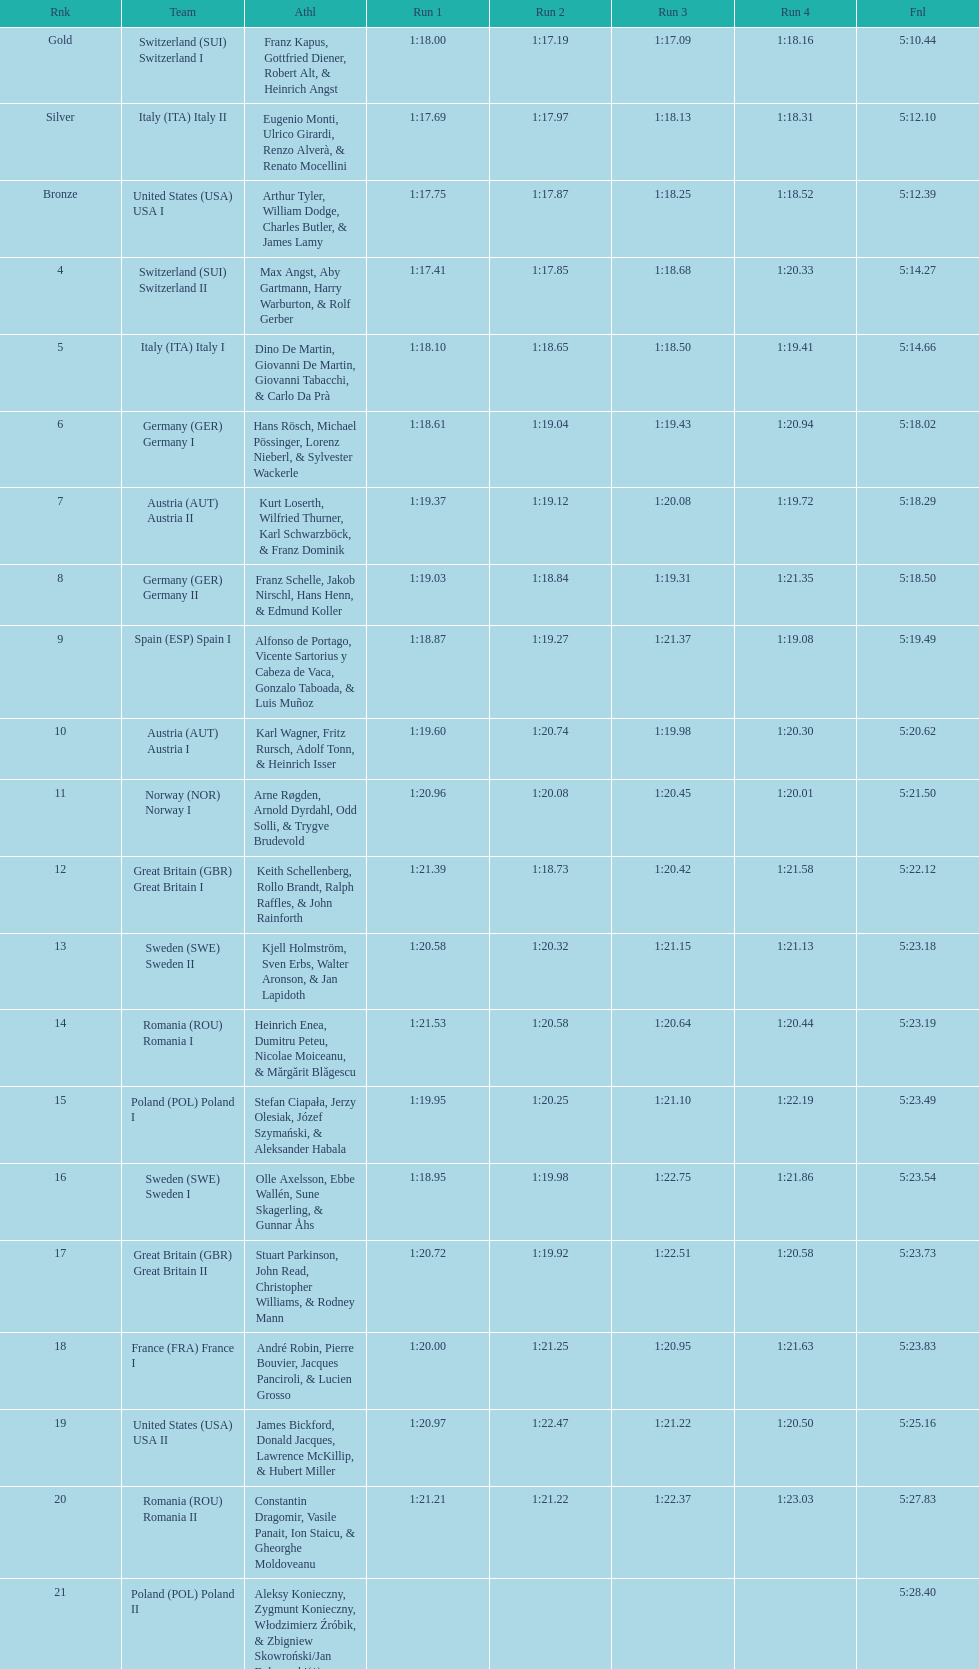Parse the full table. {'header': ['Rnk', 'Team', 'Athl', 'Run 1', 'Run 2', 'Run 3', 'Run 4', 'Fnl'], 'rows': [['Gold', 'Switzerland\xa0(SUI) Switzerland I', 'Franz Kapus, Gottfried Diener, Robert Alt, & Heinrich Angst', '1:18.00', '1:17.19', '1:17.09', '1:18.16', '5:10.44'], ['Silver', 'Italy\xa0(ITA) Italy II', 'Eugenio Monti, Ulrico Girardi, Renzo Alverà, & Renato Mocellini', '1:17.69', '1:17.97', '1:18.13', '1:18.31', '5:12.10'], ['Bronze', 'United States\xa0(USA) USA I', 'Arthur Tyler, William Dodge, Charles Butler, & James Lamy', '1:17.75', '1:17.87', '1:18.25', '1:18.52', '5:12.39'], ['4', 'Switzerland\xa0(SUI) Switzerland II', 'Max Angst, Aby Gartmann, Harry Warburton, & Rolf Gerber', '1:17.41', '1:17.85', '1:18.68', '1:20.33', '5:14.27'], ['5', 'Italy\xa0(ITA) Italy I', 'Dino De Martin, Giovanni De Martin, Giovanni Tabacchi, & Carlo Da Prà', '1:18.10', '1:18.65', '1:18.50', '1:19.41', '5:14.66'], ['6', 'Germany\xa0(GER) Germany I', 'Hans Rösch, Michael Pössinger, Lorenz Nieberl, & Sylvester Wackerle', '1:18.61', '1:19.04', '1:19.43', '1:20.94', '5:18.02'], ['7', 'Austria\xa0(AUT) Austria II', 'Kurt Loserth, Wilfried Thurner, Karl Schwarzböck, & Franz Dominik', '1:19.37', '1:19.12', '1:20.08', '1:19.72', '5:18.29'], ['8', 'Germany\xa0(GER) Germany II', 'Franz Schelle, Jakob Nirschl, Hans Henn, & Edmund Koller', '1:19.03', '1:18.84', '1:19.31', '1:21.35', '5:18.50'], ['9', 'Spain\xa0(ESP) Spain I', 'Alfonso de Portago, Vicente Sartorius y Cabeza de Vaca, Gonzalo Taboada, & Luis Muñoz', '1:18.87', '1:19.27', '1:21.37', '1:19.08', '5:19.49'], ['10', 'Austria\xa0(AUT) Austria I', 'Karl Wagner, Fritz Rursch, Adolf Tonn, & Heinrich Isser', '1:19.60', '1:20.74', '1:19.98', '1:20.30', '5:20.62'], ['11', 'Norway\xa0(NOR) Norway I', 'Arne Røgden, Arnold Dyrdahl, Odd Solli, & Trygve Brudevold', '1:20.96', '1:20.08', '1:20.45', '1:20.01', '5:21.50'], ['12', 'Great Britain\xa0(GBR) Great Britain I', 'Keith Schellenberg, Rollo Brandt, Ralph Raffles, & John Rainforth', '1:21.39', '1:18.73', '1:20.42', '1:21.58', '5:22.12'], ['13', 'Sweden\xa0(SWE) Sweden II', 'Kjell Holmström, Sven Erbs, Walter Aronson, & Jan Lapidoth', '1:20.58', '1:20.32', '1:21.15', '1:21.13', '5:23.18'], ['14', 'Romania\xa0(ROU) Romania I', 'Heinrich Enea, Dumitru Peteu, Nicolae Moiceanu, & Mărgărit Blăgescu', '1:21.53', '1:20.58', '1:20.64', '1:20.44', '5:23.19'], ['15', 'Poland\xa0(POL) Poland I', 'Stefan Ciapała, Jerzy Olesiak, Józef Szymański, & Aleksander Habala', '1:19.95', '1:20.25', '1:21.10', '1:22.19', '5:23.49'], ['16', 'Sweden\xa0(SWE) Sweden I', 'Olle Axelsson, Ebbe Wallén, Sune Skagerling, & Gunnar Åhs', '1:18.95', '1:19.98', '1:22.75', '1:21.86', '5:23.54'], ['17', 'Great Britain\xa0(GBR) Great Britain II', 'Stuart Parkinson, John Read, Christopher Williams, & Rodney Mann', '1:20.72', '1:19.92', '1:22.51', '1:20.58', '5:23.73'], ['18', 'France\xa0(FRA) France I', 'André Robin, Pierre Bouvier, Jacques Panciroli, & Lucien Grosso', '1:20.00', '1:21.25', '1:20.95', '1:21.63', '5:23.83'], ['19', 'United States\xa0(USA) USA II', 'James Bickford, Donald Jacques, Lawrence McKillip, & Hubert Miller', '1:20.97', '1:22.47', '1:21.22', '1:20.50', '5:25.16'], ['20', 'Romania\xa0(ROU) Romania II', 'Constantin Dragomir, Vasile Panait, Ion Staicu, & Gheorghe Moldoveanu', '1:21.21', '1:21.22', '1:22.37', '1:23.03', '5:27.83'], ['21', 'Poland\xa0(POL) Poland II', 'Aleksy Konieczny, Zygmunt Konieczny, Włodzimierz Źróbik, & Zbigniew Skowroński/Jan Dąbrowski(*)', '', '', '', '', '5:28.40']]} Name a country that had 4 consecutive runs under 1:19. Switzerland. 